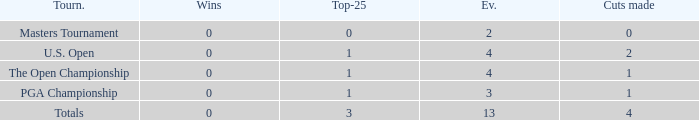How many cuts made in the tournament he played 13 times? None. 